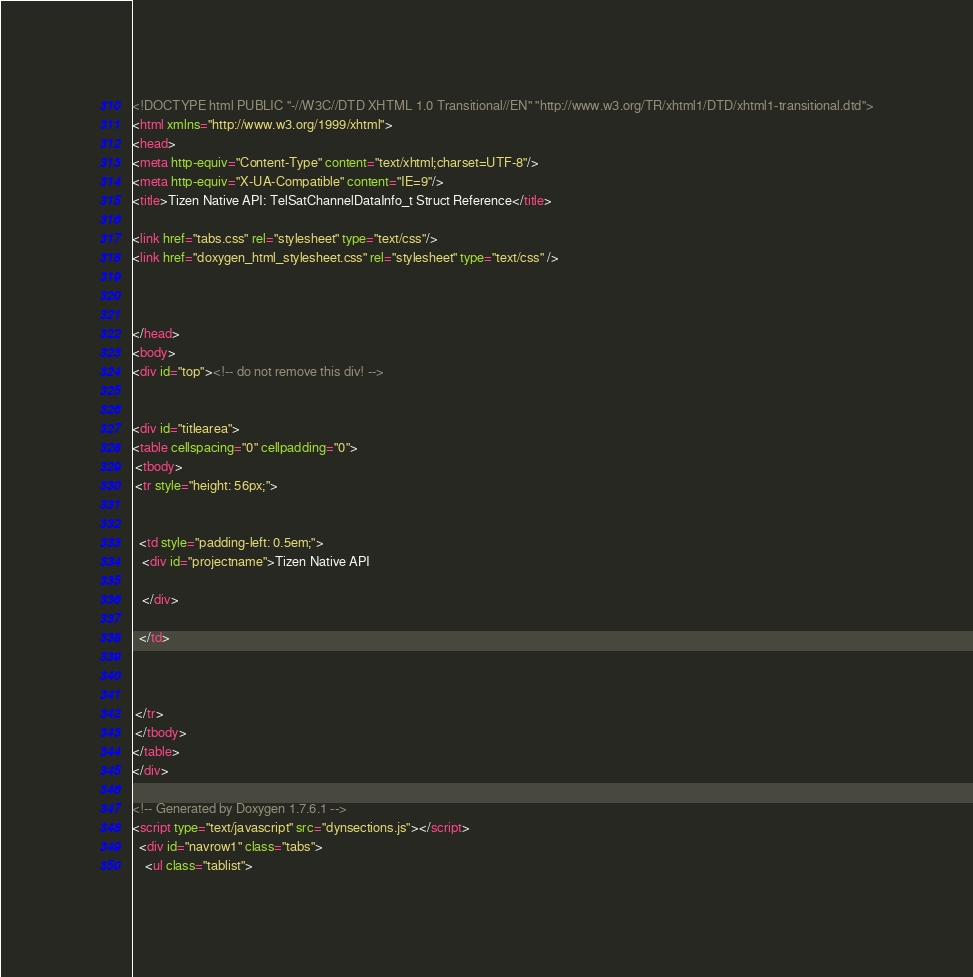<code> <loc_0><loc_0><loc_500><loc_500><_HTML_><!DOCTYPE html PUBLIC "-//W3C//DTD XHTML 1.0 Transitional//EN" "http://www.w3.org/TR/xhtml1/DTD/xhtml1-transitional.dtd">
<html xmlns="http://www.w3.org/1999/xhtml">
<head>
<meta http-equiv="Content-Type" content="text/xhtml;charset=UTF-8"/>
<meta http-equiv="X-UA-Compatible" content="IE=9"/>
<title>Tizen Native API: TelSatChannelDataInfo_t Struct Reference</title>

<link href="tabs.css" rel="stylesheet" type="text/css"/>
<link href="doxygen_html_stylesheet.css" rel="stylesheet" type="text/css" />



</head>
<body>
<div id="top"><!-- do not remove this div! -->


<div id="titlearea">
<table cellspacing="0" cellpadding="0">
 <tbody>
 <tr style="height: 56px;">
  
  
  <td style="padding-left: 0.5em;">
   <div id="projectname">Tizen Native API
   
   </div>
   
  </td>
  
  
  
 </tr>
 </tbody>
</table>
</div>

<!-- Generated by Doxygen 1.7.6.1 -->
<script type="text/javascript" src="dynsections.js"></script>
  <div id="navrow1" class="tabs">
    <ul class="tablist"></code> 